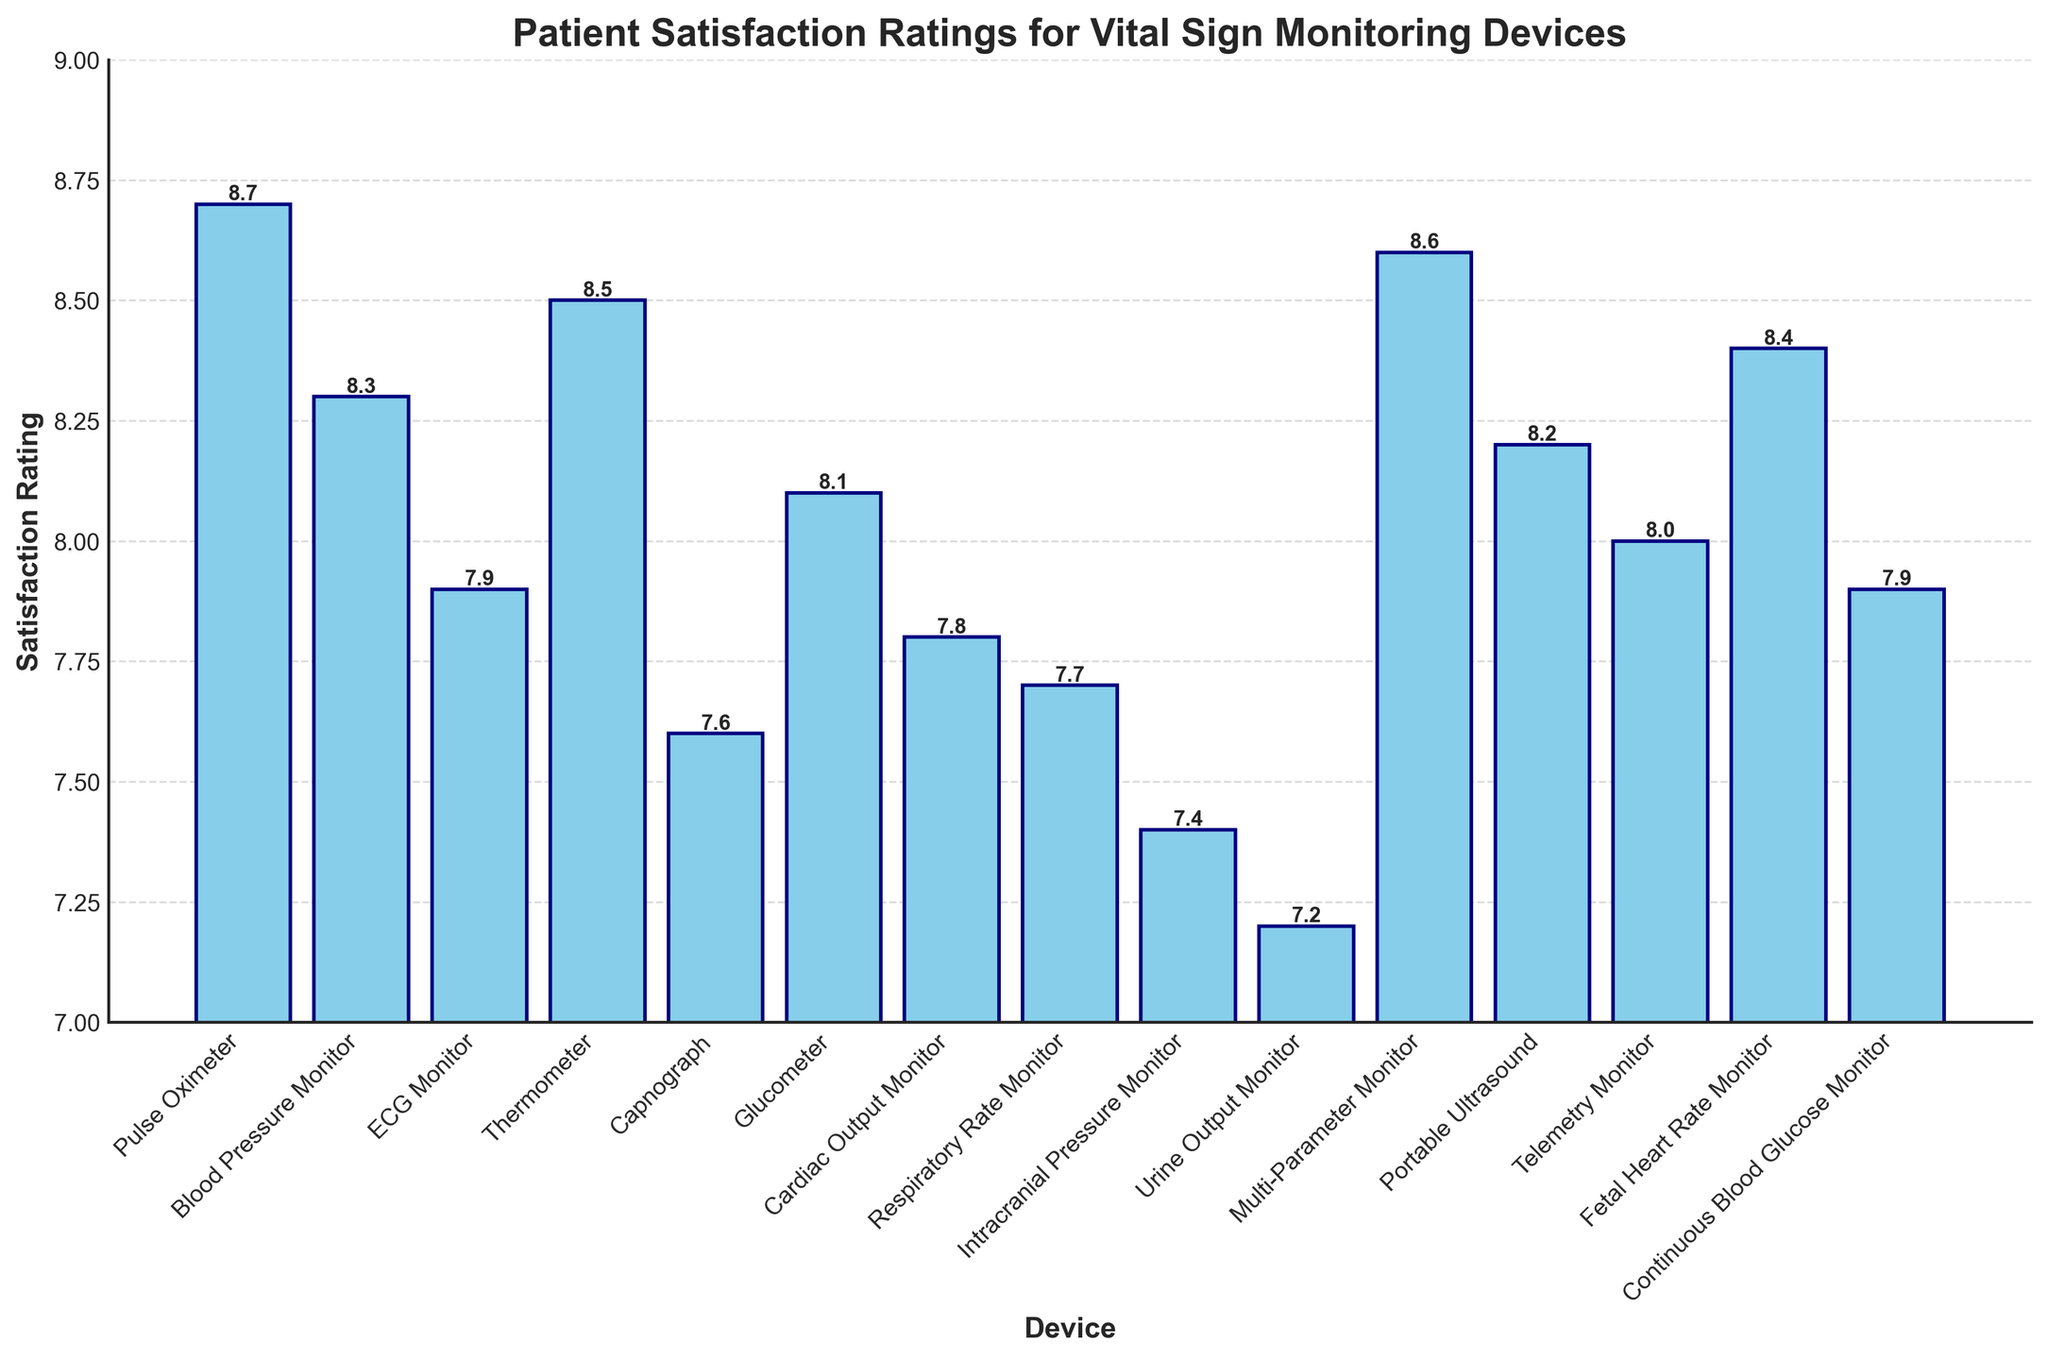which device has the highest satisfaction rating? Look for the bar that reaches the highest point on the y-axis. The Pulse Oximeter has the highest satisfaction rating as its bar reaches 8.7.
Answer: Pulse Oximeter which device has the lowest satisfaction rating? Identify the bar with the shortest height, indicating the lowest rating. The Urine Output Monitor has the lowest satisfaction rating at 7.2.
Answer: Urine Output Monitor what is the range of satisfaction ratings shown on the chart? The range is determined by subtracting the lowest rating from the highest rating (8.7 - 7.2).
Answer: 1.5 which device has a satisfaction rating closest to the median? Arrange the satisfaction ratings in numerical order and find the middle value, which is the median. The median value is between 7.9 and 8.0, and the Telemetry Monitor has a rating of 8.0, which is closest.
Answer: Telemetry Monitor how many devices have satisfaction ratings of 8.0 or higher? Count all bars with heights reaching 8.0 or more. There are 10 such devices.
Answer: 10 what is the average satisfaction rating for all the devices? Sum all the ratings and divide by the number of devices (8.7 + 8.3 + 7.9 + 8.5 + 7.6 + 8.1 + 7.8 + 7.7 + 7.4 + 7.2 + 8.6 + 8.2 + 8.0 + 8.4 + 7.9) / 15. This equals 7.98.
Answer: 7.98 which devices have a satisfaction rating greater than 8.5? Identify the bars that have heights exceeding 8.5. The Pulse Oximeter, Thermometer, and Multi-Parameter Monitor have ratings greater than 8.5.
Answer: Pulse Oximeter, Thermometer, Multi-Parameter Monitor how much higher is the satisfaction rating of the Pulse Oximeter compared to the Capnograph? Subtract the satisfaction rating of the Capnograph from that of the Pulse Oximeter (8.7 - 7.6). This equals 1.1.
Answer: 1.1 is there a significant difference between the satisfaction ratings of the Blood Pressure Monitor and the Portable Ultrasound? Compare the ratings of the two devices (8.3 for BP Monitor and 8.2 for Portable Ultrasound). The difference is 0.1, which is not significant.
Answer: No, no significant difference which three devices have the closest satisfaction ratings, and what are their values? Look for groups of adjacent bars with the smallest differences. The Cardiac Output Monitor (7.8), Respiratory Rate Monitor (7.7), and Capnograph (7.6) have the closest ratings.
Answer: Cardiac Output Monitor (7.8), Respiratory Rate Monitor (7.7), Capnograph (7.6) 